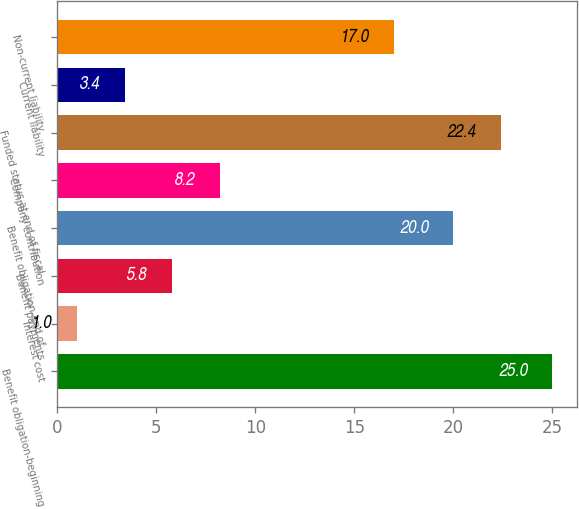Convert chart to OTSL. <chart><loc_0><loc_0><loc_500><loc_500><bar_chart><fcel>Benefit obligation-beginning<fcel>Interest cost<fcel>Benefit payments<fcel>Benefit obligation-end of<fcel>Company contribution<fcel>Funded status at end of fiscal<fcel>Current liability<fcel>Non-current liability<nl><fcel>25<fcel>1<fcel>5.8<fcel>20<fcel>8.2<fcel>22.4<fcel>3.4<fcel>17<nl></chart> 